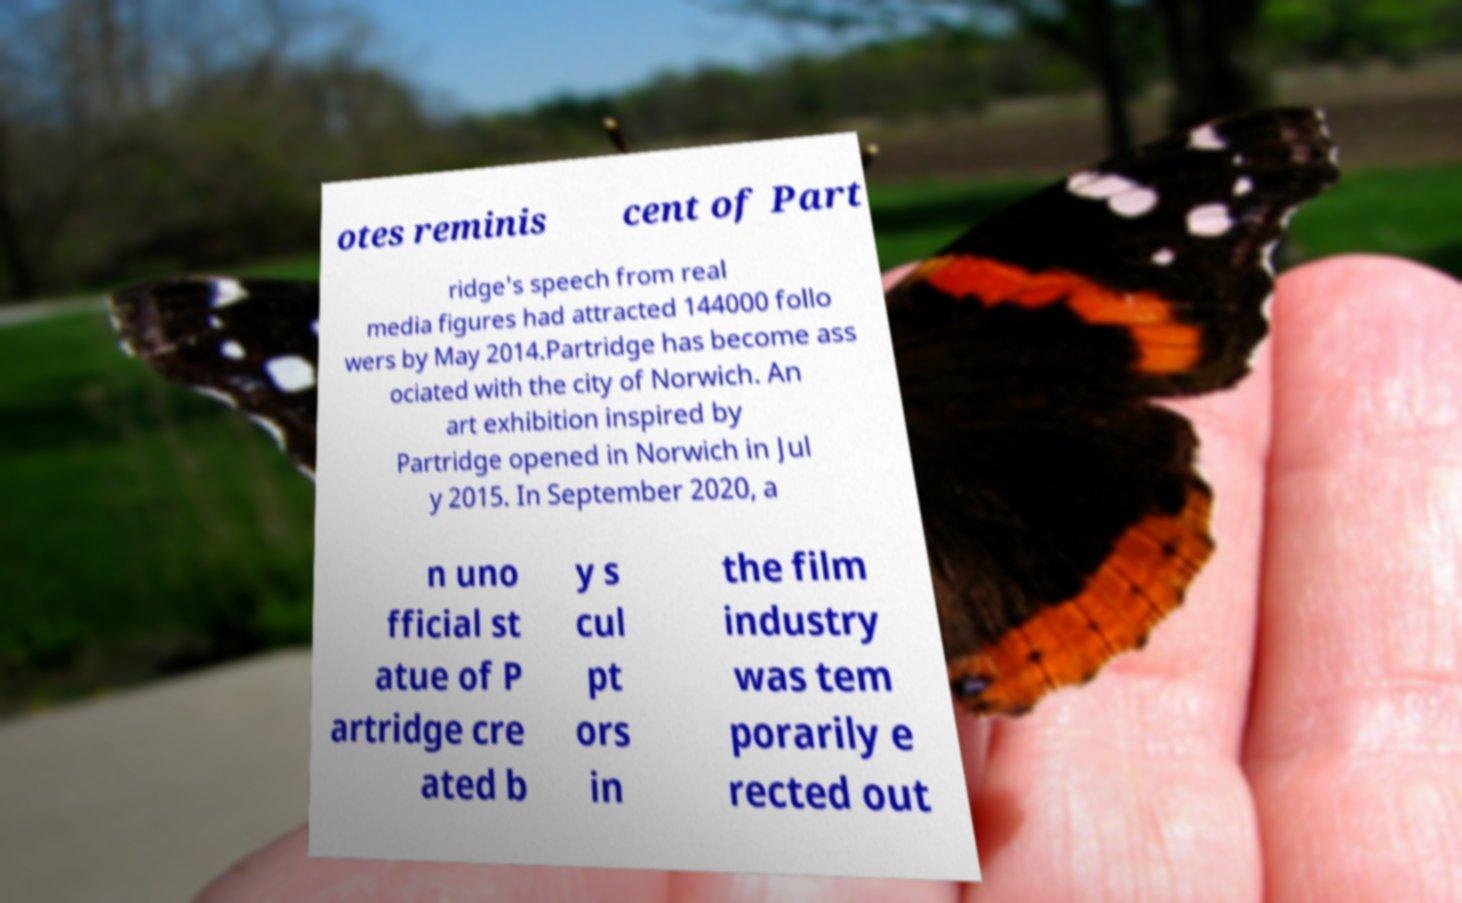Could you assist in decoding the text presented in this image and type it out clearly? otes reminis cent of Part ridge's speech from real media figures had attracted 144000 follo wers by May 2014.Partridge has become ass ociated with the city of Norwich. An art exhibition inspired by Partridge opened in Norwich in Jul y 2015. In September 2020, a n uno fficial st atue of P artridge cre ated b y s cul pt ors in the film industry was tem porarily e rected out 